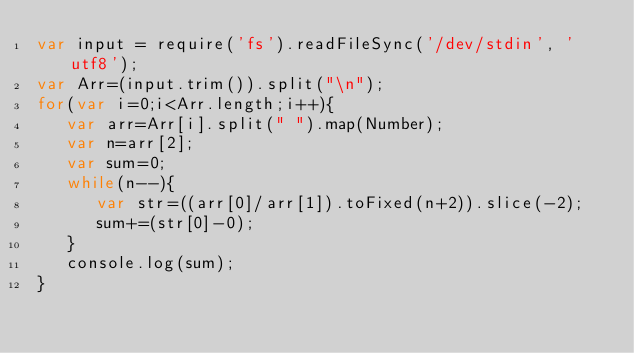Convert code to text. <code><loc_0><loc_0><loc_500><loc_500><_JavaScript_>var input = require('fs').readFileSync('/dev/stdin', 'utf8');
var Arr=(input.trim()).split("\n");
for(var i=0;i<Arr.length;i++){
   var arr=Arr[i].split(" ").map(Number);
   var n=arr[2];
   var sum=0;
   while(n--){
      var str=((arr[0]/arr[1]).toFixed(n+2)).slice(-2);
      sum+=(str[0]-0);
   }
   console.log(sum);
}</code> 